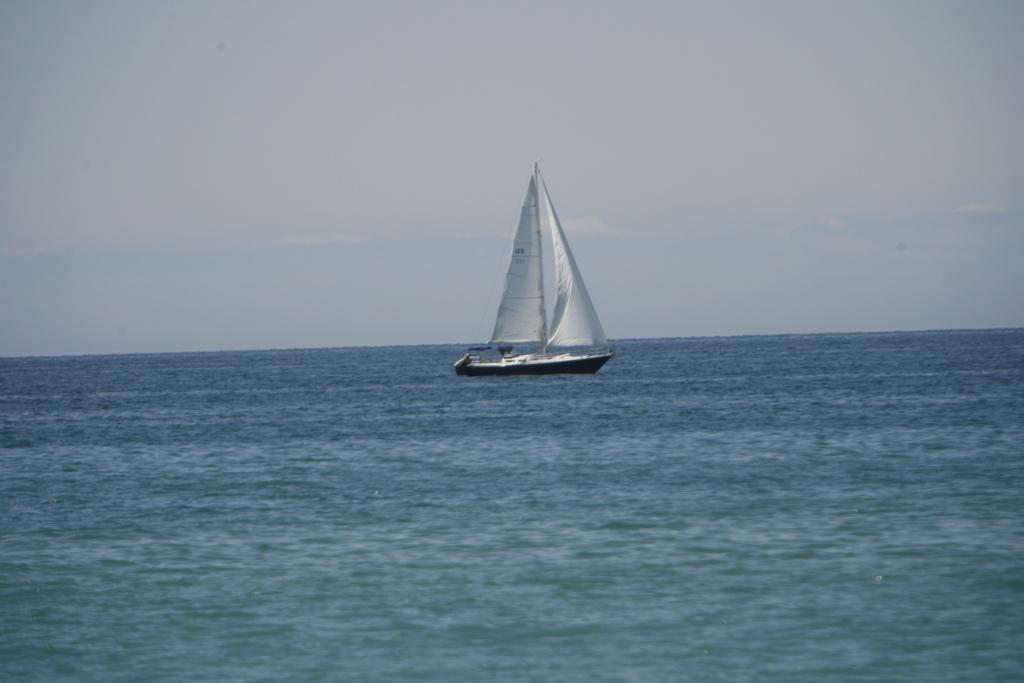What is the main subject of the image? The main subject of the image is a boat. Where is the boat located in the image? The boat is in the center of the image. What is the boat's location in relation to its surroundings? The boat is on the water. What type of finger can be seen holding onto the boat in the image? There are no fingers or hands visible in the image; it only shows a boat on the water. 